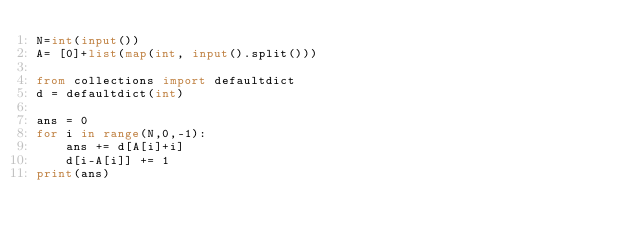Convert code to text. <code><loc_0><loc_0><loc_500><loc_500><_Python_>N=int(input())
A= [0]+list(map(int, input().split())) 

from collections import defaultdict
d = defaultdict(int)

ans = 0
for i in range(N,0,-1):
    ans += d[A[i]+i]
    d[i-A[i]] += 1
print(ans)


</code> 